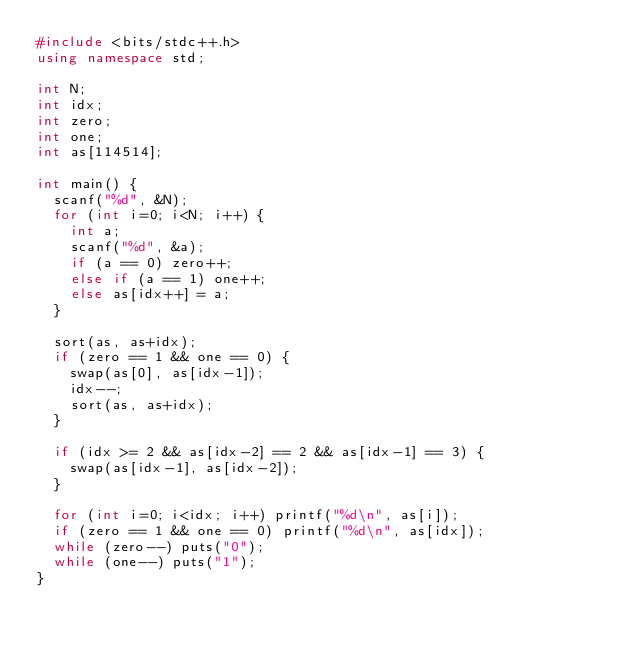Convert code to text. <code><loc_0><loc_0><loc_500><loc_500><_C++_>#include <bits/stdc++.h>
using namespace std;

int N;
int idx;
int zero;
int one;
int as[114514];

int main() {
  scanf("%d", &N);
  for (int i=0; i<N; i++) {
    int a;
    scanf("%d", &a);
    if (a == 0) zero++;
    else if (a == 1) one++;
    else as[idx++] = a;
  }

  sort(as, as+idx);
  if (zero == 1 && one == 0) {
    swap(as[0], as[idx-1]);
    idx--;
    sort(as, as+idx);
  }

  if (idx >= 2 && as[idx-2] == 2 && as[idx-1] == 3) {
    swap(as[idx-1], as[idx-2]);
  }

  for (int i=0; i<idx; i++) printf("%d\n", as[i]);
  if (zero == 1 && one == 0) printf("%d\n", as[idx]);
  while (zero--) puts("0");
  while (one--) puts("1");
}</code> 